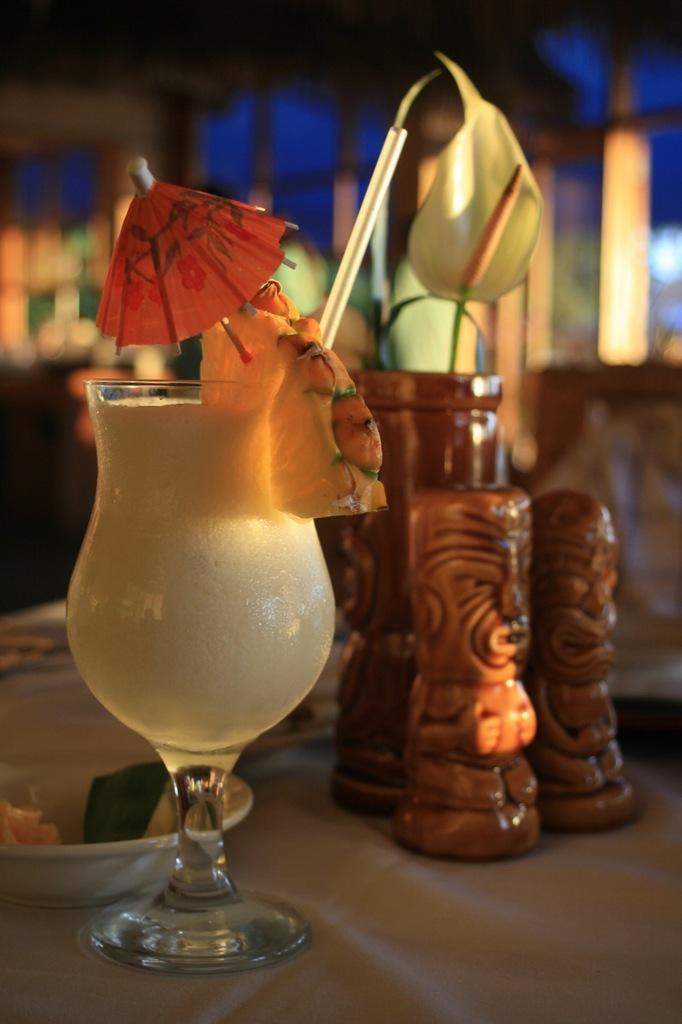Describe this image in one or two sentences. In this picture we can see few toys, bowl and a glass with drink and a straw in it, we can see blurry background. 